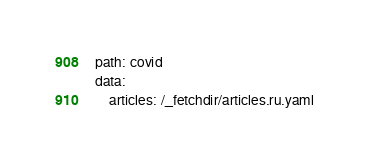Convert code to text. <code><loc_0><loc_0><loc_500><loc_500><_YAML_>path: covid
data:
    articles: /_fetchdir/articles.ru.yaml
</code> 